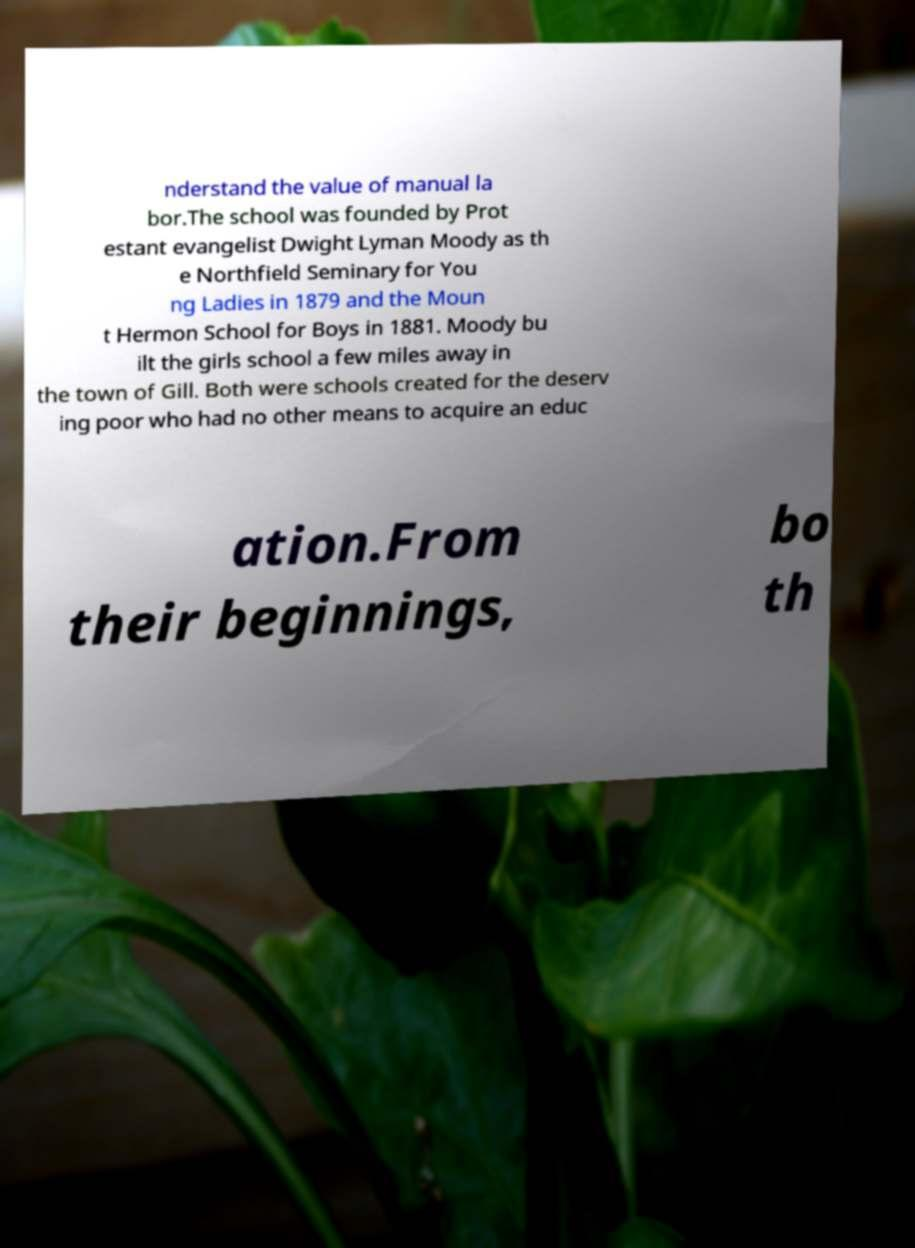There's text embedded in this image that I need extracted. Can you transcribe it verbatim? nderstand the value of manual la bor.The school was founded by Prot estant evangelist Dwight Lyman Moody as th e Northfield Seminary for You ng Ladies in 1879 and the Moun t Hermon School for Boys in 1881. Moody bu ilt the girls school a few miles away in the town of Gill. Both were schools created for the deserv ing poor who had no other means to acquire an educ ation.From their beginnings, bo th 